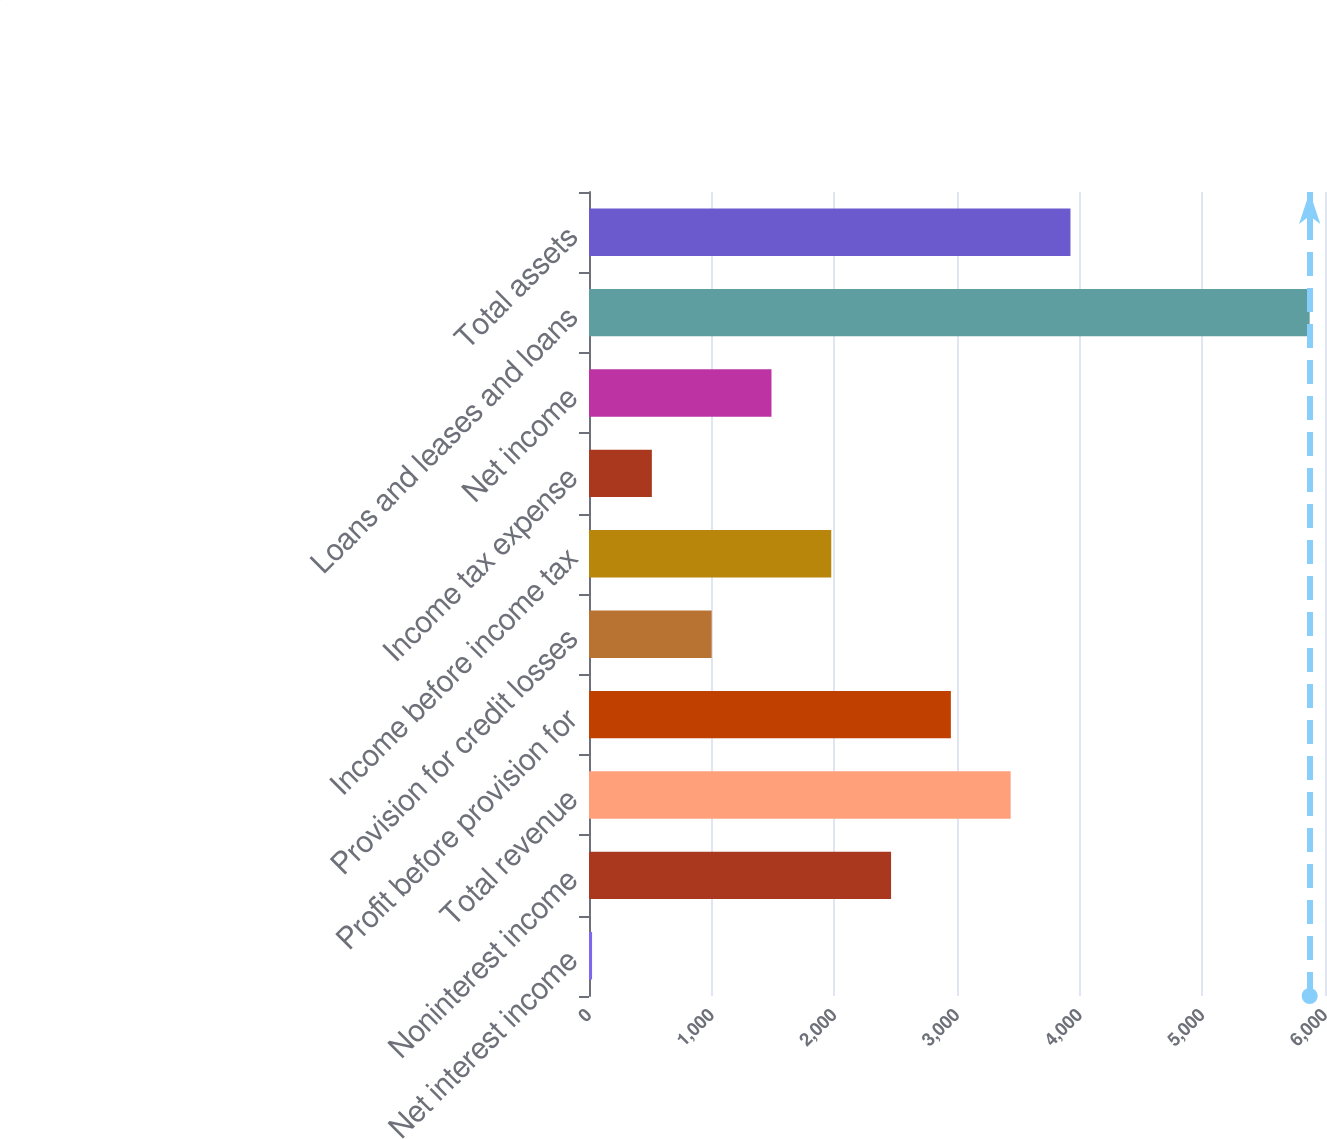Convert chart to OTSL. <chart><loc_0><loc_0><loc_500><loc_500><bar_chart><fcel>Net interest income<fcel>Noninterest income<fcel>Total revenue<fcel>Profit before provision for<fcel>Provision for credit losses<fcel>Income before income tax<fcel>Income tax expense<fcel>Net income<fcel>Loans and leases and loans<fcel>Total assets<nl><fcel>25<fcel>2462.5<fcel>3437.5<fcel>2950<fcel>1000<fcel>1975<fcel>512.5<fcel>1487.5<fcel>5875<fcel>3925<nl></chart> 